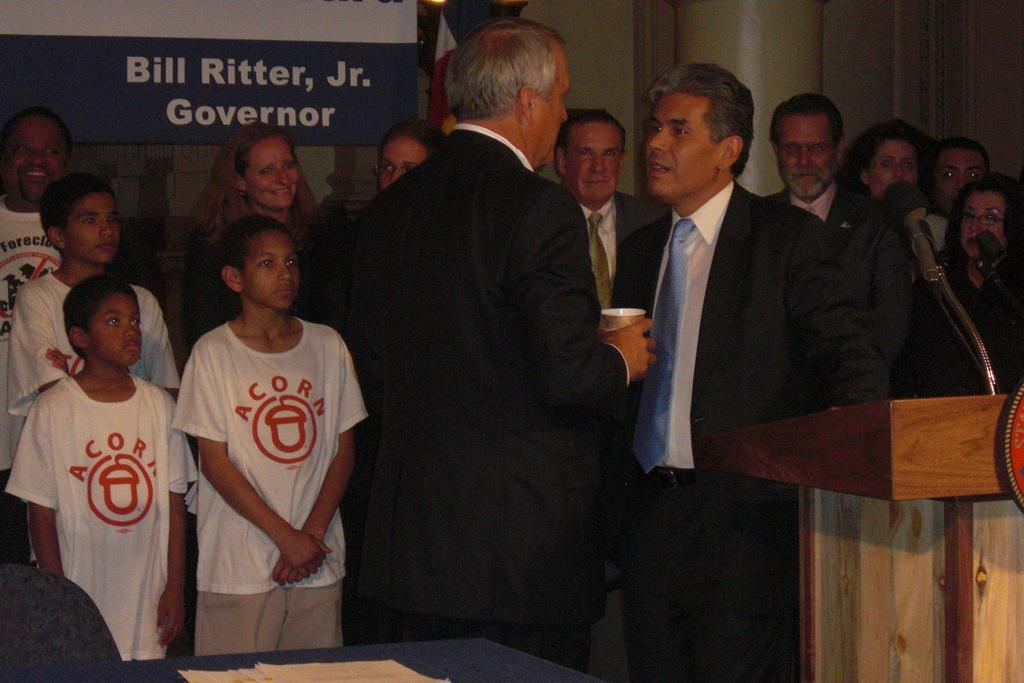Provide a one-sentence caption for the provided image. Two men talking in front of a group of people watching who are in front of a sign that says, "Bill Ritter, Jr. Governor". 